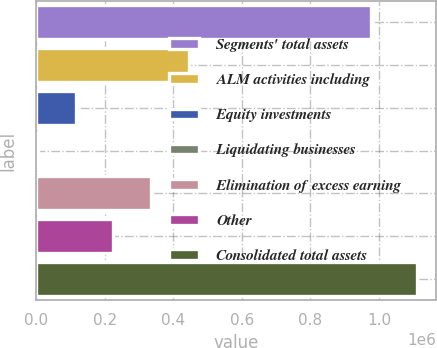Convert chart to OTSL. <chart><loc_0><loc_0><loc_500><loc_500><bar_chart><fcel>Segments' total assets<fcel>ALM activities including<fcel>Equity investments<fcel>Liquidating businesses<fcel>Elimination of excess earning<fcel>Other<fcel>Consolidated total assets<nl><fcel>977431<fcel>446807<fcel>114994<fcel>4390<fcel>336203<fcel>225598<fcel>1.11043e+06<nl></chart> 